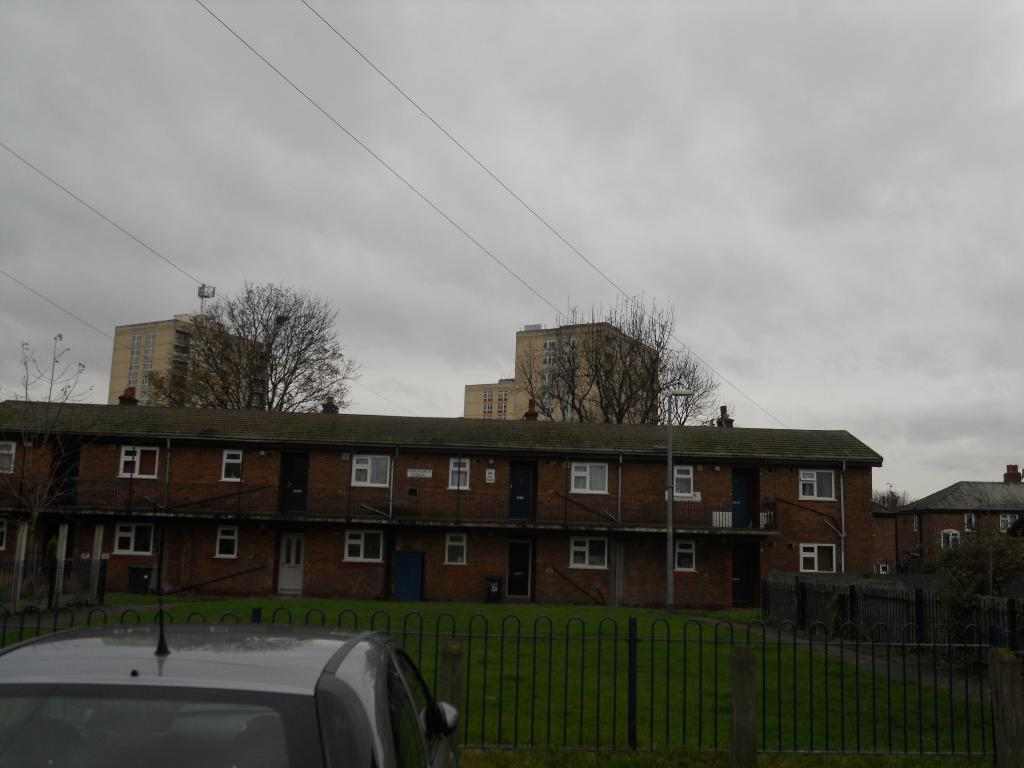What is located in the center of the image? There are buildings, trees, and poles in the center of the image. What type of vegetation is present in the image? There are trees in the center of the image. What is at the bottom of the image? There is grass and a car at the bottom of the image. What is the condition of the sky in the image? The sky is cloudy at the top of the image. What else can be seen in the image? Wires are visible in the image. What type of cheese is being used to construct the buildings in the image? There is no cheese present in the image; the buildings are made of conventional materials. What degree of difficulty is required to walk on the floor in the image? There is no floor present in the image, as it is an outdoor scene with grass at the bottom. 